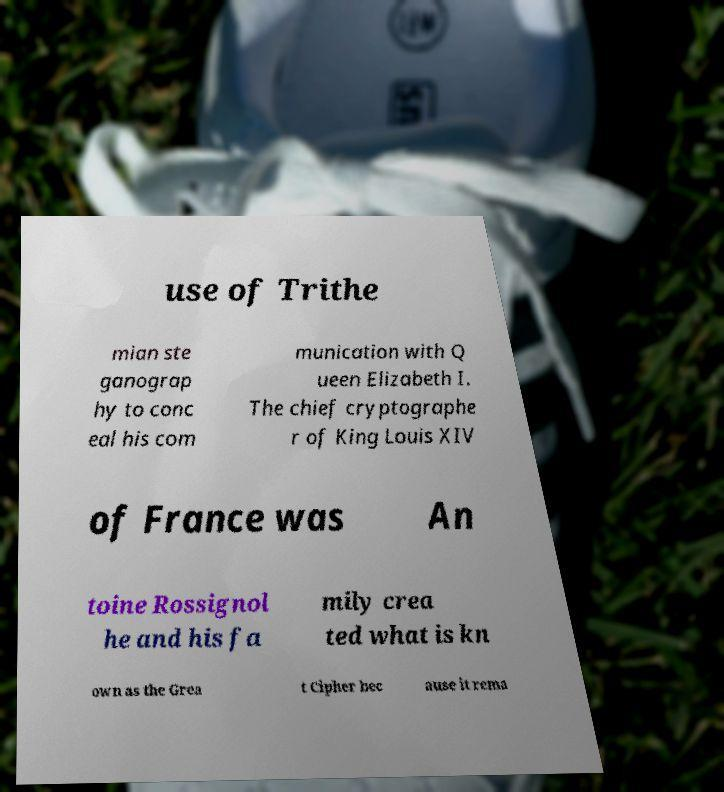Could you extract and type out the text from this image? use of Trithe mian ste ganograp hy to conc eal his com munication with Q ueen Elizabeth I. The chief cryptographe r of King Louis XIV of France was An toine Rossignol he and his fa mily crea ted what is kn own as the Grea t Cipher bec ause it rema 